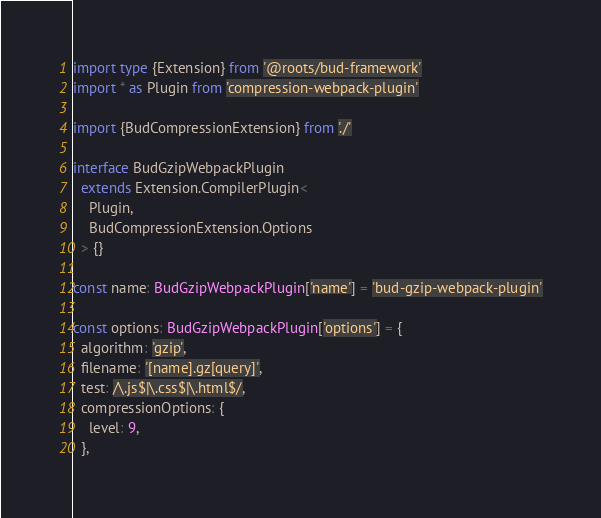Convert code to text. <code><loc_0><loc_0><loc_500><loc_500><_TypeScript_>import type {Extension} from '@roots/bud-framework'
import * as Plugin from 'compression-webpack-plugin'

import {BudCompressionExtension} from './'

interface BudGzipWebpackPlugin
  extends Extension.CompilerPlugin<
    Plugin,
    BudCompressionExtension.Options
  > {}

const name: BudGzipWebpackPlugin['name'] = 'bud-gzip-webpack-plugin'

const options: BudGzipWebpackPlugin['options'] = {
  algorithm: 'gzip',
  filename: '[name].gz[query]',
  test: /\.js$|\.css$|\.html$/,
  compressionOptions: {
    level: 9,
  },</code> 